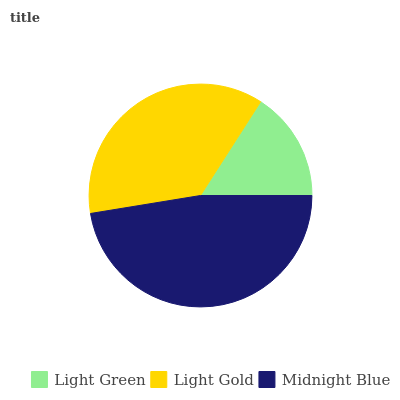Is Light Green the minimum?
Answer yes or no. Yes. Is Midnight Blue the maximum?
Answer yes or no. Yes. Is Light Gold the minimum?
Answer yes or no. No. Is Light Gold the maximum?
Answer yes or no. No. Is Light Gold greater than Light Green?
Answer yes or no. Yes. Is Light Green less than Light Gold?
Answer yes or no. Yes. Is Light Green greater than Light Gold?
Answer yes or no. No. Is Light Gold less than Light Green?
Answer yes or no. No. Is Light Gold the high median?
Answer yes or no. Yes. Is Light Gold the low median?
Answer yes or no. Yes. Is Light Green the high median?
Answer yes or no. No. Is Light Green the low median?
Answer yes or no. No. 